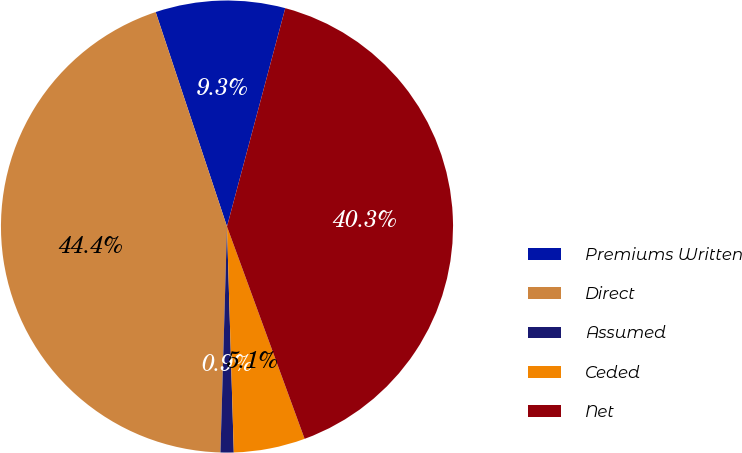Convert chart. <chart><loc_0><loc_0><loc_500><loc_500><pie_chart><fcel>Premiums Written<fcel>Direct<fcel>Assumed<fcel>Ceded<fcel>Net<nl><fcel>9.26%<fcel>44.43%<fcel>0.94%<fcel>5.1%<fcel>40.27%<nl></chart> 